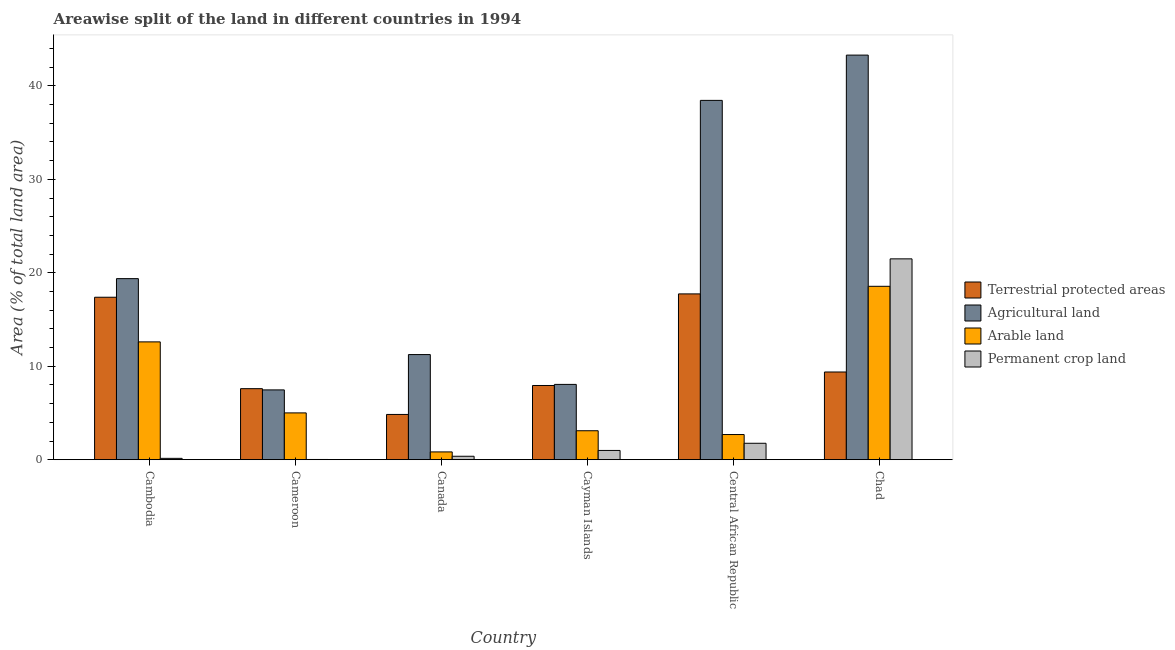How many groups of bars are there?
Your answer should be very brief. 6. Are the number of bars per tick equal to the number of legend labels?
Your answer should be very brief. Yes. Are the number of bars on each tick of the X-axis equal?
Offer a terse response. Yes. What is the label of the 4th group of bars from the left?
Offer a terse response. Cayman Islands. In how many cases, is the number of bars for a given country not equal to the number of legend labels?
Ensure brevity in your answer.  0. What is the percentage of area under agricultural land in Cambodia?
Your answer should be compact. 19.38. Across all countries, what is the maximum percentage of area under arable land?
Keep it short and to the point. 18.56. Across all countries, what is the minimum percentage of land under terrestrial protection?
Offer a terse response. 4.84. In which country was the percentage of land under terrestrial protection maximum?
Give a very brief answer. Central African Republic. In which country was the percentage of area under permanent crop land minimum?
Your answer should be compact. Cameroon. What is the total percentage of area under agricultural land in the graph?
Make the answer very short. 127.91. What is the difference between the percentage of area under arable land in Central African Republic and that in Chad?
Keep it short and to the point. -15.86. What is the difference between the percentage of land under terrestrial protection in Cayman Islands and the percentage of area under permanent crop land in Central African Republic?
Give a very brief answer. 6.18. What is the average percentage of area under permanent crop land per country?
Provide a short and direct response. 4.13. What is the difference between the percentage of area under arable land and percentage of area under permanent crop land in Chad?
Your answer should be very brief. -2.94. What is the ratio of the percentage of area under arable land in Canada to that in Central African Republic?
Ensure brevity in your answer.  0.31. Is the difference between the percentage of area under agricultural land in Cameroon and Central African Republic greater than the difference between the percentage of area under arable land in Cameroon and Central African Republic?
Give a very brief answer. No. What is the difference between the highest and the second highest percentage of area under arable land?
Provide a short and direct response. 5.95. What is the difference between the highest and the lowest percentage of area under permanent crop land?
Your response must be concise. 21.47. Is the sum of the percentage of area under permanent crop land in Cayman Islands and Chad greater than the maximum percentage of land under terrestrial protection across all countries?
Make the answer very short. Yes. What does the 3rd bar from the left in Cameroon represents?
Your answer should be compact. Arable land. What does the 1st bar from the right in Cayman Islands represents?
Make the answer very short. Permanent crop land. Is it the case that in every country, the sum of the percentage of land under terrestrial protection and percentage of area under agricultural land is greater than the percentage of area under arable land?
Keep it short and to the point. Yes. Are all the bars in the graph horizontal?
Make the answer very short. No. Are the values on the major ticks of Y-axis written in scientific E-notation?
Your answer should be very brief. No. Does the graph contain any zero values?
Make the answer very short. No. Does the graph contain grids?
Offer a very short reply. No. Where does the legend appear in the graph?
Offer a very short reply. Center right. How are the legend labels stacked?
Give a very brief answer. Vertical. What is the title of the graph?
Keep it short and to the point. Areawise split of the land in different countries in 1994. What is the label or title of the X-axis?
Your answer should be compact. Country. What is the label or title of the Y-axis?
Provide a succinct answer. Area (% of total land area). What is the Area (% of total land area) in Terrestrial protected areas in Cambodia?
Your answer should be very brief. 17.39. What is the Area (% of total land area) of Agricultural land in Cambodia?
Provide a succinct answer. 19.38. What is the Area (% of total land area) of Arable land in Cambodia?
Give a very brief answer. 12.61. What is the Area (% of total land area) in Permanent crop land in Cambodia?
Your response must be concise. 0.14. What is the Area (% of total land area) in Terrestrial protected areas in Cameroon?
Provide a short and direct response. 7.6. What is the Area (% of total land area) of Agricultural land in Cameroon?
Make the answer very short. 7.47. What is the Area (% of total land area) of Arable land in Cameroon?
Ensure brevity in your answer.  5.01. What is the Area (% of total land area) of Permanent crop land in Cameroon?
Keep it short and to the point. 0.02. What is the Area (% of total land area) of Terrestrial protected areas in Canada?
Offer a terse response. 4.84. What is the Area (% of total land area) of Agricultural land in Canada?
Offer a terse response. 11.25. What is the Area (% of total land area) of Arable land in Canada?
Your response must be concise. 0.83. What is the Area (% of total land area) in Permanent crop land in Canada?
Your response must be concise. 0.37. What is the Area (% of total land area) in Terrestrial protected areas in Cayman Islands?
Your answer should be very brief. 7.94. What is the Area (% of total land area) in Agricultural land in Cayman Islands?
Give a very brief answer. 8.06. What is the Area (% of total land area) in Arable land in Cayman Islands?
Ensure brevity in your answer.  3.1. What is the Area (% of total land area) in Permanent crop land in Cayman Islands?
Keep it short and to the point. 0.99. What is the Area (% of total land area) of Terrestrial protected areas in Central African Republic?
Give a very brief answer. 17.74. What is the Area (% of total land area) in Agricultural land in Central African Republic?
Make the answer very short. 38.45. What is the Area (% of total land area) in Arable land in Central African Republic?
Provide a short and direct response. 2.69. What is the Area (% of total land area) in Permanent crop land in Central African Republic?
Give a very brief answer. 1.76. What is the Area (% of total land area) of Terrestrial protected areas in Chad?
Provide a succinct answer. 9.39. What is the Area (% of total land area) in Agricultural land in Chad?
Provide a short and direct response. 43.3. What is the Area (% of total land area) of Arable land in Chad?
Your answer should be very brief. 18.56. What is the Area (% of total land area) in Permanent crop land in Chad?
Your answer should be very brief. 21.49. Across all countries, what is the maximum Area (% of total land area) of Terrestrial protected areas?
Your answer should be very brief. 17.74. Across all countries, what is the maximum Area (% of total land area) in Agricultural land?
Offer a very short reply. 43.3. Across all countries, what is the maximum Area (% of total land area) in Arable land?
Provide a short and direct response. 18.56. Across all countries, what is the maximum Area (% of total land area) in Permanent crop land?
Your answer should be very brief. 21.49. Across all countries, what is the minimum Area (% of total land area) in Terrestrial protected areas?
Your answer should be compact. 4.84. Across all countries, what is the minimum Area (% of total land area) of Agricultural land?
Provide a short and direct response. 7.47. Across all countries, what is the minimum Area (% of total land area) in Arable land?
Offer a terse response. 0.83. Across all countries, what is the minimum Area (% of total land area) of Permanent crop land?
Your answer should be compact. 0.02. What is the total Area (% of total land area) of Terrestrial protected areas in the graph?
Ensure brevity in your answer.  64.9. What is the total Area (% of total land area) of Agricultural land in the graph?
Offer a terse response. 127.91. What is the total Area (% of total land area) of Arable land in the graph?
Give a very brief answer. 42.8. What is the total Area (% of total land area) of Permanent crop land in the graph?
Offer a very short reply. 24.78. What is the difference between the Area (% of total land area) of Terrestrial protected areas in Cambodia and that in Cameroon?
Offer a very short reply. 9.78. What is the difference between the Area (% of total land area) of Agricultural land in Cambodia and that in Cameroon?
Give a very brief answer. 11.91. What is the difference between the Area (% of total land area) of Arable land in Cambodia and that in Cameroon?
Keep it short and to the point. 7.6. What is the difference between the Area (% of total land area) in Permanent crop land in Cambodia and that in Cameroon?
Provide a short and direct response. 0.12. What is the difference between the Area (% of total land area) of Terrestrial protected areas in Cambodia and that in Canada?
Give a very brief answer. 12.54. What is the difference between the Area (% of total land area) of Agricultural land in Cambodia and that in Canada?
Your response must be concise. 8.13. What is the difference between the Area (% of total land area) of Arable land in Cambodia and that in Canada?
Give a very brief answer. 11.77. What is the difference between the Area (% of total land area) of Permanent crop land in Cambodia and that in Canada?
Offer a very short reply. -0.22. What is the difference between the Area (% of total land area) in Terrestrial protected areas in Cambodia and that in Cayman Islands?
Offer a terse response. 9.45. What is the difference between the Area (% of total land area) in Agricultural land in Cambodia and that in Cayman Islands?
Ensure brevity in your answer.  11.32. What is the difference between the Area (% of total land area) in Arable land in Cambodia and that in Cayman Islands?
Make the answer very short. 9.51. What is the difference between the Area (% of total land area) of Permanent crop land in Cambodia and that in Cayman Islands?
Make the answer very short. -0.85. What is the difference between the Area (% of total land area) in Terrestrial protected areas in Cambodia and that in Central African Republic?
Provide a succinct answer. -0.36. What is the difference between the Area (% of total land area) of Agricultural land in Cambodia and that in Central African Republic?
Your response must be concise. -19.08. What is the difference between the Area (% of total land area) in Arable land in Cambodia and that in Central African Republic?
Your response must be concise. 9.92. What is the difference between the Area (% of total land area) in Permanent crop land in Cambodia and that in Central African Republic?
Make the answer very short. -1.61. What is the difference between the Area (% of total land area) in Terrestrial protected areas in Cambodia and that in Chad?
Your response must be concise. 8. What is the difference between the Area (% of total land area) of Agricultural land in Cambodia and that in Chad?
Offer a terse response. -23.92. What is the difference between the Area (% of total land area) in Arable land in Cambodia and that in Chad?
Your response must be concise. -5.95. What is the difference between the Area (% of total land area) in Permanent crop land in Cambodia and that in Chad?
Your response must be concise. -21.35. What is the difference between the Area (% of total land area) of Terrestrial protected areas in Cameroon and that in Canada?
Provide a succinct answer. 2.76. What is the difference between the Area (% of total land area) in Agricultural land in Cameroon and that in Canada?
Offer a very short reply. -3.78. What is the difference between the Area (% of total land area) in Arable land in Cameroon and that in Canada?
Provide a succinct answer. 4.18. What is the difference between the Area (% of total land area) of Permanent crop land in Cameroon and that in Canada?
Make the answer very short. -0.34. What is the difference between the Area (% of total land area) of Terrestrial protected areas in Cameroon and that in Cayman Islands?
Your answer should be compact. -0.34. What is the difference between the Area (% of total land area) of Agricultural land in Cameroon and that in Cayman Islands?
Your answer should be compact. -0.59. What is the difference between the Area (% of total land area) in Arable land in Cameroon and that in Cayman Islands?
Keep it short and to the point. 1.91. What is the difference between the Area (% of total land area) in Permanent crop land in Cameroon and that in Cayman Islands?
Provide a succinct answer. -0.97. What is the difference between the Area (% of total land area) of Terrestrial protected areas in Cameroon and that in Central African Republic?
Your response must be concise. -10.14. What is the difference between the Area (% of total land area) in Agricultural land in Cameroon and that in Central African Republic?
Make the answer very short. -30.98. What is the difference between the Area (% of total land area) in Arable land in Cameroon and that in Central African Republic?
Provide a short and direct response. 2.32. What is the difference between the Area (% of total land area) in Permanent crop land in Cameroon and that in Central African Republic?
Make the answer very short. -1.73. What is the difference between the Area (% of total land area) in Terrestrial protected areas in Cameroon and that in Chad?
Your response must be concise. -1.78. What is the difference between the Area (% of total land area) of Agricultural land in Cameroon and that in Chad?
Your answer should be very brief. -35.83. What is the difference between the Area (% of total land area) in Arable land in Cameroon and that in Chad?
Ensure brevity in your answer.  -13.55. What is the difference between the Area (% of total land area) in Permanent crop land in Cameroon and that in Chad?
Keep it short and to the point. -21.47. What is the difference between the Area (% of total land area) of Terrestrial protected areas in Canada and that in Cayman Islands?
Keep it short and to the point. -3.1. What is the difference between the Area (% of total land area) in Agricultural land in Canada and that in Cayman Islands?
Provide a short and direct response. 3.19. What is the difference between the Area (% of total land area) of Arable land in Canada and that in Cayman Islands?
Provide a succinct answer. -2.26. What is the difference between the Area (% of total land area) in Permanent crop land in Canada and that in Cayman Islands?
Make the answer very short. -0.62. What is the difference between the Area (% of total land area) in Terrestrial protected areas in Canada and that in Central African Republic?
Make the answer very short. -12.9. What is the difference between the Area (% of total land area) in Agricultural land in Canada and that in Central African Republic?
Your response must be concise. -27.2. What is the difference between the Area (% of total land area) of Arable land in Canada and that in Central African Republic?
Offer a very short reply. -1.86. What is the difference between the Area (% of total land area) in Permanent crop land in Canada and that in Central African Republic?
Your answer should be very brief. -1.39. What is the difference between the Area (% of total land area) of Terrestrial protected areas in Canada and that in Chad?
Your answer should be compact. -4.54. What is the difference between the Area (% of total land area) in Agricultural land in Canada and that in Chad?
Your answer should be very brief. -32.05. What is the difference between the Area (% of total land area) in Arable land in Canada and that in Chad?
Provide a succinct answer. -17.72. What is the difference between the Area (% of total land area) in Permanent crop land in Canada and that in Chad?
Your answer should be compact. -21.13. What is the difference between the Area (% of total land area) in Terrestrial protected areas in Cayman Islands and that in Central African Republic?
Keep it short and to the point. -9.8. What is the difference between the Area (% of total land area) in Agricultural land in Cayman Islands and that in Central African Republic?
Make the answer very short. -30.39. What is the difference between the Area (% of total land area) in Arable land in Cayman Islands and that in Central African Republic?
Offer a terse response. 0.41. What is the difference between the Area (% of total land area) of Permanent crop land in Cayman Islands and that in Central African Republic?
Offer a very short reply. -0.77. What is the difference between the Area (% of total land area) of Terrestrial protected areas in Cayman Islands and that in Chad?
Provide a succinct answer. -1.45. What is the difference between the Area (% of total land area) of Agricultural land in Cayman Islands and that in Chad?
Your answer should be very brief. -35.24. What is the difference between the Area (% of total land area) in Arable land in Cayman Islands and that in Chad?
Provide a short and direct response. -15.46. What is the difference between the Area (% of total land area) in Permanent crop land in Cayman Islands and that in Chad?
Keep it short and to the point. -20.5. What is the difference between the Area (% of total land area) of Terrestrial protected areas in Central African Republic and that in Chad?
Keep it short and to the point. 8.36. What is the difference between the Area (% of total land area) in Agricultural land in Central African Republic and that in Chad?
Offer a very short reply. -4.85. What is the difference between the Area (% of total land area) of Arable land in Central African Republic and that in Chad?
Offer a very short reply. -15.86. What is the difference between the Area (% of total land area) of Permanent crop land in Central African Republic and that in Chad?
Keep it short and to the point. -19.74. What is the difference between the Area (% of total land area) in Terrestrial protected areas in Cambodia and the Area (% of total land area) in Agricultural land in Cameroon?
Give a very brief answer. 9.92. What is the difference between the Area (% of total land area) of Terrestrial protected areas in Cambodia and the Area (% of total land area) of Arable land in Cameroon?
Offer a terse response. 12.38. What is the difference between the Area (% of total land area) of Terrestrial protected areas in Cambodia and the Area (% of total land area) of Permanent crop land in Cameroon?
Give a very brief answer. 17.36. What is the difference between the Area (% of total land area) of Agricultural land in Cambodia and the Area (% of total land area) of Arable land in Cameroon?
Provide a succinct answer. 14.37. What is the difference between the Area (% of total land area) of Agricultural land in Cambodia and the Area (% of total land area) of Permanent crop land in Cameroon?
Your answer should be very brief. 19.35. What is the difference between the Area (% of total land area) in Arable land in Cambodia and the Area (% of total land area) in Permanent crop land in Cameroon?
Provide a succinct answer. 12.58. What is the difference between the Area (% of total land area) in Terrestrial protected areas in Cambodia and the Area (% of total land area) in Agricultural land in Canada?
Your answer should be very brief. 6.14. What is the difference between the Area (% of total land area) of Terrestrial protected areas in Cambodia and the Area (% of total land area) of Arable land in Canada?
Provide a succinct answer. 16.55. What is the difference between the Area (% of total land area) in Terrestrial protected areas in Cambodia and the Area (% of total land area) in Permanent crop land in Canada?
Make the answer very short. 17.02. What is the difference between the Area (% of total land area) in Agricultural land in Cambodia and the Area (% of total land area) in Arable land in Canada?
Provide a succinct answer. 18.54. What is the difference between the Area (% of total land area) of Agricultural land in Cambodia and the Area (% of total land area) of Permanent crop land in Canada?
Keep it short and to the point. 19.01. What is the difference between the Area (% of total land area) in Arable land in Cambodia and the Area (% of total land area) in Permanent crop land in Canada?
Your answer should be very brief. 12.24. What is the difference between the Area (% of total land area) of Terrestrial protected areas in Cambodia and the Area (% of total land area) of Agricultural land in Cayman Islands?
Ensure brevity in your answer.  9.33. What is the difference between the Area (% of total land area) in Terrestrial protected areas in Cambodia and the Area (% of total land area) in Arable land in Cayman Islands?
Offer a very short reply. 14.29. What is the difference between the Area (% of total land area) of Terrestrial protected areas in Cambodia and the Area (% of total land area) of Permanent crop land in Cayman Islands?
Your response must be concise. 16.4. What is the difference between the Area (% of total land area) of Agricultural land in Cambodia and the Area (% of total land area) of Arable land in Cayman Islands?
Your answer should be very brief. 16.28. What is the difference between the Area (% of total land area) of Agricultural land in Cambodia and the Area (% of total land area) of Permanent crop land in Cayman Islands?
Make the answer very short. 18.39. What is the difference between the Area (% of total land area) in Arable land in Cambodia and the Area (% of total land area) in Permanent crop land in Cayman Islands?
Ensure brevity in your answer.  11.62. What is the difference between the Area (% of total land area) in Terrestrial protected areas in Cambodia and the Area (% of total land area) in Agricultural land in Central African Republic?
Provide a succinct answer. -21.07. What is the difference between the Area (% of total land area) in Terrestrial protected areas in Cambodia and the Area (% of total land area) in Arable land in Central African Republic?
Provide a succinct answer. 14.69. What is the difference between the Area (% of total land area) of Terrestrial protected areas in Cambodia and the Area (% of total land area) of Permanent crop land in Central African Republic?
Your answer should be very brief. 15.63. What is the difference between the Area (% of total land area) of Agricultural land in Cambodia and the Area (% of total land area) of Arable land in Central African Republic?
Give a very brief answer. 16.69. What is the difference between the Area (% of total land area) in Agricultural land in Cambodia and the Area (% of total land area) in Permanent crop land in Central African Republic?
Your answer should be very brief. 17.62. What is the difference between the Area (% of total land area) in Arable land in Cambodia and the Area (% of total land area) in Permanent crop land in Central African Republic?
Provide a succinct answer. 10.85. What is the difference between the Area (% of total land area) of Terrestrial protected areas in Cambodia and the Area (% of total land area) of Agricultural land in Chad?
Offer a terse response. -25.91. What is the difference between the Area (% of total land area) of Terrestrial protected areas in Cambodia and the Area (% of total land area) of Arable land in Chad?
Give a very brief answer. -1.17. What is the difference between the Area (% of total land area) in Terrestrial protected areas in Cambodia and the Area (% of total land area) in Permanent crop land in Chad?
Keep it short and to the point. -4.11. What is the difference between the Area (% of total land area) in Agricultural land in Cambodia and the Area (% of total land area) in Arable land in Chad?
Offer a terse response. 0.82. What is the difference between the Area (% of total land area) in Agricultural land in Cambodia and the Area (% of total land area) in Permanent crop land in Chad?
Offer a terse response. -2.12. What is the difference between the Area (% of total land area) of Arable land in Cambodia and the Area (% of total land area) of Permanent crop land in Chad?
Offer a very short reply. -8.89. What is the difference between the Area (% of total land area) in Terrestrial protected areas in Cameroon and the Area (% of total land area) in Agricultural land in Canada?
Offer a terse response. -3.65. What is the difference between the Area (% of total land area) of Terrestrial protected areas in Cameroon and the Area (% of total land area) of Arable land in Canada?
Ensure brevity in your answer.  6.77. What is the difference between the Area (% of total land area) of Terrestrial protected areas in Cameroon and the Area (% of total land area) of Permanent crop land in Canada?
Provide a succinct answer. 7.23. What is the difference between the Area (% of total land area) in Agricultural land in Cameroon and the Area (% of total land area) in Arable land in Canada?
Your answer should be very brief. 6.64. What is the difference between the Area (% of total land area) of Agricultural land in Cameroon and the Area (% of total land area) of Permanent crop land in Canada?
Your answer should be very brief. 7.1. What is the difference between the Area (% of total land area) in Arable land in Cameroon and the Area (% of total land area) in Permanent crop land in Canada?
Ensure brevity in your answer.  4.64. What is the difference between the Area (% of total land area) in Terrestrial protected areas in Cameroon and the Area (% of total land area) in Agricultural land in Cayman Islands?
Ensure brevity in your answer.  -0.46. What is the difference between the Area (% of total land area) of Terrestrial protected areas in Cameroon and the Area (% of total land area) of Arable land in Cayman Islands?
Offer a very short reply. 4.5. What is the difference between the Area (% of total land area) in Terrestrial protected areas in Cameroon and the Area (% of total land area) in Permanent crop land in Cayman Islands?
Keep it short and to the point. 6.61. What is the difference between the Area (% of total land area) in Agricultural land in Cameroon and the Area (% of total land area) in Arable land in Cayman Islands?
Your response must be concise. 4.37. What is the difference between the Area (% of total land area) of Agricultural land in Cameroon and the Area (% of total land area) of Permanent crop land in Cayman Islands?
Give a very brief answer. 6.48. What is the difference between the Area (% of total land area) of Arable land in Cameroon and the Area (% of total land area) of Permanent crop land in Cayman Islands?
Keep it short and to the point. 4.02. What is the difference between the Area (% of total land area) of Terrestrial protected areas in Cameroon and the Area (% of total land area) of Agricultural land in Central African Republic?
Keep it short and to the point. -30.85. What is the difference between the Area (% of total land area) in Terrestrial protected areas in Cameroon and the Area (% of total land area) in Arable land in Central African Republic?
Offer a very short reply. 4.91. What is the difference between the Area (% of total land area) in Terrestrial protected areas in Cameroon and the Area (% of total land area) in Permanent crop land in Central African Republic?
Offer a terse response. 5.84. What is the difference between the Area (% of total land area) in Agricultural land in Cameroon and the Area (% of total land area) in Arable land in Central African Republic?
Make the answer very short. 4.78. What is the difference between the Area (% of total land area) in Agricultural land in Cameroon and the Area (% of total land area) in Permanent crop land in Central African Republic?
Keep it short and to the point. 5.71. What is the difference between the Area (% of total land area) in Arable land in Cameroon and the Area (% of total land area) in Permanent crop land in Central African Republic?
Offer a very short reply. 3.25. What is the difference between the Area (% of total land area) in Terrestrial protected areas in Cameroon and the Area (% of total land area) in Agricultural land in Chad?
Provide a succinct answer. -35.7. What is the difference between the Area (% of total land area) of Terrestrial protected areas in Cameroon and the Area (% of total land area) of Arable land in Chad?
Offer a terse response. -10.95. What is the difference between the Area (% of total land area) in Terrestrial protected areas in Cameroon and the Area (% of total land area) in Permanent crop land in Chad?
Offer a very short reply. -13.89. What is the difference between the Area (% of total land area) in Agricultural land in Cameroon and the Area (% of total land area) in Arable land in Chad?
Your answer should be very brief. -11.09. What is the difference between the Area (% of total land area) of Agricultural land in Cameroon and the Area (% of total land area) of Permanent crop land in Chad?
Your answer should be very brief. -14.02. What is the difference between the Area (% of total land area) of Arable land in Cameroon and the Area (% of total land area) of Permanent crop land in Chad?
Provide a short and direct response. -16.49. What is the difference between the Area (% of total land area) of Terrestrial protected areas in Canada and the Area (% of total land area) of Agricultural land in Cayman Islands?
Keep it short and to the point. -3.22. What is the difference between the Area (% of total land area) of Terrestrial protected areas in Canada and the Area (% of total land area) of Arable land in Cayman Islands?
Provide a short and direct response. 1.74. What is the difference between the Area (% of total land area) in Terrestrial protected areas in Canada and the Area (% of total land area) in Permanent crop land in Cayman Islands?
Your response must be concise. 3.85. What is the difference between the Area (% of total land area) in Agricultural land in Canada and the Area (% of total land area) in Arable land in Cayman Islands?
Offer a terse response. 8.15. What is the difference between the Area (% of total land area) of Agricultural land in Canada and the Area (% of total land area) of Permanent crop land in Cayman Islands?
Give a very brief answer. 10.26. What is the difference between the Area (% of total land area) in Arable land in Canada and the Area (% of total land area) in Permanent crop land in Cayman Islands?
Offer a very short reply. -0.16. What is the difference between the Area (% of total land area) in Terrestrial protected areas in Canada and the Area (% of total land area) in Agricultural land in Central African Republic?
Offer a terse response. -33.61. What is the difference between the Area (% of total land area) of Terrestrial protected areas in Canada and the Area (% of total land area) of Arable land in Central African Republic?
Your response must be concise. 2.15. What is the difference between the Area (% of total land area) in Terrestrial protected areas in Canada and the Area (% of total land area) in Permanent crop land in Central African Republic?
Your response must be concise. 3.08. What is the difference between the Area (% of total land area) of Agricultural land in Canada and the Area (% of total land area) of Arable land in Central African Republic?
Your response must be concise. 8.56. What is the difference between the Area (% of total land area) in Agricultural land in Canada and the Area (% of total land area) in Permanent crop land in Central African Republic?
Make the answer very short. 9.49. What is the difference between the Area (% of total land area) in Arable land in Canada and the Area (% of total land area) in Permanent crop land in Central African Republic?
Keep it short and to the point. -0.92. What is the difference between the Area (% of total land area) of Terrestrial protected areas in Canada and the Area (% of total land area) of Agricultural land in Chad?
Make the answer very short. -38.46. What is the difference between the Area (% of total land area) in Terrestrial protected areas in Canada and the Area (% of total land area) in Arable land in Chad?
Provide a short and direct response. -13.71. What is the difference between the Area (% of total land area) of Terrestrial protected areas in Canada and the Area (% of total land area) of Permanent crop land in Chad?
Provide a short and direct response. -16.65. What is the difference between the Area (% of total land area) of Agricultural land in Canada and the Area (% of total land area) of Arable land in Chad?
Give a very brief answer. -7.31. What is the difference between the Area (% of total land area) of Agricultural land in Canada and the Area (% of total land area) of Permanent crop land in Chad?
Your answer should be very brief. -10.24. What is the difference between the Area (% of total land area) in Arable land in Canada and the Area (% of total land area) in Permanent crop land in Chad?
Make the answer very short. -20.66. What is the difference between the Area (% of total land area) in Terrestrial protected areas in Cayman Islands and the Area (% of total land area) in Agricultural land in Central African Republic?
Offer a terse response. -30.51. What is the difference between the Area (% of total land area) in Terrestrial protected areas in Cayman Islands and the Area (% of total land area) in Arable land in Central African Republic?
Your answer should be compact. 5.25. What is the difference between the Area (% of total land area) of Terrestrial protected areas in Cayman Islands and the Area (% of total land area) of Permanent crop land in Central African Republic?
Keep it short and to the point. 6.18. What is the difference between the Area (% of total land area) in Agricultural land in Cayman Islands and the Area (% of total land area) in Arable land in Central African Republic?
Offer a very short reply. 5.37. What is the difference between the Area (% of total land area) of Agricultural land in Cayman Islands and the Area (% of total land area) of Permanent crop land in Central African Republic?
Provide a short and direct response. 6.3. What is the difference between the Area (% of total land area) in Arable land in Cayman Islands and the Area (% of total land area) in Permanent crop land in Central African Republic?
Keep it short and to the point. 1.34. What is the difference between the Area (% of total land area) of Terrestrial protected areas in Cayman Islands and the Area (% of total land area) of Agricultural land in Chad?
Offer a very short reply. -35.36. What is the difference between the Area (% of total land area) in Terrestrial protected areas in Cayman Islands and the Area (% of total land area) in Arable land in Chad?
Provide a short and direct response. -10.62. What is the difference between the Area (% of total land area) of Terrestrial protected areas in Cayman Islands and the Area (% of total land area) of Permanent crop land in Chad?
Your response must be concise. -13.55. What is the difference between the Area (% of total land area) in Agricultural land in Cayman Islands and the Area (% of total land area) in Arable land in Chad?
Offer a terse response. -10.5. What is the difference between the Area (% of total land area) in Agricultural land in Cayman Islands and the Area (% of total land area) in Permanent crop land in Chad?
Make the answer very short. -13.44. What is the difference between the Area (% of total land area) of Arable land in Cayman Islands and the Area (% of total land area) of Permanent crop land in Chad?
Offer a terse response. -18.4. What is the difference between the Area (% of total land area) of Terrestrial protected areas in Central African Republic and the Area (% of total land area) of Agricultural land in Chad?
Ensure brevity in your answer.  -25.55. What is the difference between the Area (% of total land area) of Terrestrial protected areas in Central African Republic and the Area (% of total land area) of Arable land in Chad?
Offer a terse response. -0.81. What is the difference between the Area (% of total land area) of Terrestrial protected areas in Central African Republic and the Area (% of total land area) of Permanent crop land in Chad?
Provide a short and direct response. -3.75. What is the difference between the Area (% of total land area) of Agricultural land in Central African Republic and the Area (% of total land area) of Arable land in Chad?
Keep it short and to the point. 19.9. What is the difference between the Area (% of total land area) in Agricultural land in Central African Republic and the Area (% of total land area) in Permanent crop land in Chad?
Offer a terse response. 16.96. What is the difference between the Area (% of total land area) of Arable land in Central African Republic and the Area (% of total land area) of Permanent crop land in Chad?
Provide a succinct answer. -18.8. What is the average Area (% of total land area) of Terrestrial protected areas per country?
Offer a terse response. 10.82. What is the average Area (% of total land area) in Agricultural land per country?
Keep it short and to the point. 21.32. What is the average Area (% of total land area) of Arable land per country?
Provide a short and direct response. 7.13. What is the average Area (% of total land area) of Permanent crop land per country?
Offer a terse response. 4.13. What is the difference between the Area (% of total land area) in Terrestrial protected areas and Area (% of total land area) in Agricultural land in Cambodia?
Offer a very short reply. -1.99. What is the difference between the Area (% of total land area) in Terrestrial protected areas and Area (% of total land area) in Arable land in Cambodia?
Give a very brief answer. 4.78. What is the difference between the Area (% of total land area) of Terrestrial protected areas and Area (% of total land area) of Permanent crop land in Cambodia?
Make the answer very short. 17.24. What is the difference between the Area (% of total land area) in Agricultural land and Area (% of total land area) in Arable land in Cambodia?
Keep it short and to the point. 6.77. What is the difference between the Area (% of total land area) in Agricultural land and Area (% of total land area) in Permanent crop land in Cambodia?
Your response must be concise. 19.23. What is the difference between the Area (% of total land area) of Arable land and Area (% of total land area) of Permanent crop land in Cambodia?
Your response must be concise. 12.46. What is the difference between the Area (% of total land area) in Terrestrial protected areas and Area (% of total land area) in Agricultural land in Cameroon?
Make the answer very short. 0.13. What is the difference between the Area (% of total land area) of Terrestrial protected areas and Area (% of total land area) of Arable land in Cameroon?
Provide a succinct answer. 2.59. What is the difference between the Area (% of total land area) of Terrestrial protected areas and Area (% of total land area) of Permanent crop land in Cameroon?
Offer a very short reply. 7.58. What is the difference between the Area (% of total land area) of Agricultural land and Area (% of total land area) of Arable land in Cameroon?
Offer a very short reply. 2.46. What is the difference between the Area (% of total land area) of Agricultural land and Area (% of total land area) of Permanent crop land in Cameroon?
Your answer should be compact. 7.45. What is the difference between the Area (% of total land area) in Arable land and Area (% of total land area) in Permanent crop land in Cameroon?
Your response must be concise. 4.98. What is the difference between the Area (% of total land area) of Terrestrial protected areas and Area (% of total land area) of Agricultural land in Canada?
Keep it short and to the point. -6.41. What is the difference between the Area (% of total land area) of Terrestrial protected areas and Area (% of total land area) of Arable land in Canada?
Offer a very short reply. 4.01. What is the difference between the Area (% of total land area) of Terrestrial protected areas and Area (% of total land area) of Permanent crop land in Canada?
Ensure brevity in your answer.  4.47. What is the difference between the Area (% of total land area) of Agricultural land and Area (% of total land area) of Arable land in Canada?
Provide a short and direct response. 10.42. What is the difference between the Area (% of total land area) in Agricultural land and Area (% of total land area) in Permanent crop land in Canada?
Your answer should be very brief. 10.88. What is the difference between the Area (% of total land area) of Arable land and Area (% of total land area) of Permanent crop land in Canada?
Give a very brief answer. 0.46. What is the difference between the Area (% of total land area) in Terrestrial protected areas and Area (% of total land area) in Agricultural land in Cayman Islands?
Provide a short and direct response. -0.12. What is the difference between the Area (% of total land area) of Terrestrial protected areas and Area (% of total land area) of Arable land in Cayman Islands?
Keep it short and to the point. 4.84. What is the difference between the Area (% of total land area) of Terrestrial protected areas and Area (% of total land area) of Permanent crop land in Cayman Islands?
Your response must be concise. 6.95. What is the difference between the Area (% of total land area) in Agricultural land and Area (% of total land area) in Arable land in Cayman Islands?
Provide a succinct answer. 4.96. What is the difference between the Area (% of total land area) of Agricultural land and Area (% of total land area) of Permanent crop land in Cayman Islands?
Provide a short and direct response. 7.07. What is the difference between the Area (% of total land area) of Arable land and Area (% of total land area) of Permanent crop land in Cayman Islands?
Provide a short and direct response. 2.11. What is the difference between the Area (% of total land area) in Terrestrial protected areas and Area (% of total land area) in Agricultural land in Central African Republic?
Ensure brevity in your answer.  -20.71. What is the difference between the Area (% of total land area) in Terrestrial protected areas and Area (% of total land area) in Arable land in Central African Republic?
Provide a succinct answer. 15.05. What is the difference between the Area (% of total land area) in Terrestrial protected areas and Area (% of total land area) in Permanent crop land in Central African Republic?
Keep it short and to the point. 15.99. What is the difference between the Area (% of total land area) of Agricultural land and Area (% of total land area) of Arable land in Central African Republic?
Ensure brevity in your answer.  35.76. What is the difference between the Area (% of total land area) in Agricultural land and Area (% of total land area) in Permanent crop land in Central African Republic?
Offer a very short reply. 36.7. What is the difference between the Area (% of total land area) of Arable land and Area (% of total land area) of Permanent crop land in Central African Republic?
Keep it short and to the point. 0.93. What is the difference between the Area (% of total land area) of Terrestrial protected areas and Area (% of total land area) of Agricultural land in Chad?
Your answer should be compact. -33.91. What is the difference between the Area (% of total land area) of Terrestrial protected areas and Area (% of total land area) of Arable land in Chad?
Keep it short and to the point. -9.17. What is the difference between the Area (% of total land area) in Terrestrial protected areas and Area (% of total land area) in Permanent crop land in Chad?
Provide a succinct answer. -12.11. What is the difference between the Area (% of total land area) in Agricultural land and Area (% of total land area) in Arable land in Chad?
Make the answer very short. 24.74. What is the difference between the Area (% of total land area) in Agricultural land and Area (% of total land area) in Permanent crop land in Chad?
Your answer should be compact. 21.81. What is the difference between the Area (% of total land area) in Arable land and Area (% of total land area) in Permanent crop land in Chad?
Offer a very short reply. -2.94. What is the ratio of the Area (% of total land area) in Terrestrial protected areas in Cambodia to that in Cameroon?
Ensure brevity in your answer.  2.29. What is the ratio of the Area (% of total land area) of Agricultural land in Cambodia to that in Cameroon?
Make the answer very short. 2.59. What is the ratio of the Area (% of total land area) of Arable land in Cambodia to that in Cameroon?
Your answer should be compact. 2.52. What is the ratio of the Area (% of total land area) in Permanent crop land in Cambodia to that in Cameroon?
Offer a very short reply. 6.06. What is the ratio of the Area (% of total land area) in Terrestrial protected areas in Cambodia to that in Canada?
Make the answer very short. 3.59. What is the ratio of the Area (% of total land area) of Agricultural land in Cambodia to that in Canada?
Ensure brevity in your answer.  1.72. What is the ratio of the Area (% of total land area) in Arable land in Cambodia to that in Canada?
Your answer should be very brief. 15.13. What is the ratio of the Area (% of total land area) in Permanent crop land in Cambodia to that in Canada?
Your answer should be very brief. 0.39. What is the ratio of the Area (% of total land area) in Terrestrial protected areas in Cambodia to that in Cayman Islands?
Your answer should be very brief. 2.19. What is the ratio of the Area (% of total land area) in Agricultural land in Cambodia to that in Cayman Islands?
Offer a terse response. 2.4. What is the ratio of the Area (% of total land area) of Arable land in Cambodia to that in Cayman Islands?
Your answer should be compact. 4.07. What is the ratio of the Area (% of total land area) in Permanent crop land in Cambodia to that in Cayman Islands?
Provide a short and direct response. 0.15. What is the ratio of the Area (% of total land area) of Terrestrial protected areas in Cambodia to that in Central African Republic?
Ensure brevity in your answer.  0.98. What is the ratio of the Area (% of total land area) of Agricultural land in Cambodia to that in Central African Republic?
Your answer should be very brief. 0.5. What is the ratio of the Area (% of total land area) in Arable land in Cambodia to that in Central African Republic?
Keep it short and to the point. 4.68. What is the ratio of the Area (% of total land area) of Permanent crop land in Cambodia to that in Central African Republic?
Offer a terse response. 0.08. What is the ratio of the Area (% of total land area) of Terrestrial protected areas in Cambodia to that in Chad?
Offer a very short reply. 1.85. What is the ratio of the Area (% of total land area) of Agricultural land in Cambodia to that in Chad?
Make the answer very short. 0.45. What is the ratio of the Area (% of total land area) of Arable land in Cambodia to that in Chad?
Your answer should be very brief. 0.68. What is the ratio of the Area (% of total land area) in Permanent crop land in Cambodia to that in Chad?
Your answer should be compact. 0.01. What is the ratio of the Area (% of total land area) of Terrestrial protected areas in Cameroon to that in Canada?
Provide a succinct answer. 1.57. What is the ratio of the Area (% of total land area) of Agricultural land in Cameroon to that in Canada?
Offer a terse response. 0.66. What is the ratio of the Area (% of total land area) of Arable land in Cameroon to that in Canada?
Give a very brief answer. 6.01. What is the ratio of the Area (% of total land area) in Permanent crop land in Cameroon to that in Canada?
Offer a terse response. 0.06. What is the ratio of the Area (% of total land area) of Terrestrial protected areas in Cameroon to that in Cayman Islands?
Your response must be concise. 0.96. What is the ratio of the Area (% of total land area) in Agricultural land in Cameroon to that in Cayman Islands?
Offer a terse response. 0.93. What is the ratio of the Area (% of total land area) of Arable land in Cameroon to that in Cayman Islands?
Provide a succinct answer. 1.62. What is the ratio of the Area (% of total land area) in Permanent crop land in Cameroon to that in Cayman Islands?
Your answer should be very brief. 0.02. What is the ratio of the Area (% of total land area) in Terrestrial protected areas in Cameroon to that in Central African Republic?
Your answer should be compact. 0.43. What is the ratio of the Area (% of total land area) in Agricultural land in Cameroon to that in Central African Republic?
Keep it short and to the point. 0.19. What is the ratio of the Area (% of total land area) in Arable land in Cameroon to that in Central African Republic?
Give a very brief answer. 1.86. What is the ratio of the Area (% of total land area) of Permanent crop land in Cameroon to that in Central African Republic?
Offer a terse response. 0.01. What is the ratio of the Area (% of total land area) in Terrestrial protected areas in Cameroon to that in Chad?
Your response must be concise. 0.81. What is the ratio of the Area (% of total land area) of Agricultural land in Cameroon to that in Chad?
Keep it short and to the point. 0.17. What is the ratio of the Area (% of total land area) in Arable land in Cameroon to that in Chad?
Your answer should be very brief. 0.27. What is the ratio of the Area (% of total land area) of Permanent crop land in Cameroon to that in Chad?
Provide a short and direct response. 0. What is the ratio of the Area (% of total land area) in Terrestrial protected areas in Canada to that in Cayman Islands?
Offer a very short reply. 0.61. What is the ratio of the Area (% of total land area) of Agricultural land in Canada to that in Cayman Islands?
Offer a very short reply. 1.4. What is the ratio of the Area (% of total land area) in Arable land in Canada to that in Cayman Islands?
Your answer should be compact. 0.27. What is the ratio of the Area (% of total land area) of Permanent crop land in Canada to that in Cayman Islands?
Make the answer very short. 0.37. What is the ratio of the Area (% of total land area) of Terrestrial protected areas in Canada to that in Central African Republic?
Make the answer very short. 0.27. What is the ratio of the Area (% of total land area) of Agricultural land in Canada to that in Central African Republic?
Provide a short and direct response. 0.29. What is the ratio of the Area (% of total land area) in Arable land in Canada to that in Central African Republic?
Offer a very short reply. 0.31. What is the ratio of the Area (% of total land area) of Permanent crop land in Canada to that in Central African Republic?
Your answer should be compact. 0.21. What is the ratio of the Area (% of total land area) in Terrestrial protected areas in Canada to that in Chad?
Your response must be concise. 0.52. What is the ratio of the Area (% of total land area) of Agricultural land in Canada to that in Chad?
Ensure brevity in your answer.  0.26. What is the ratio of the Area (% of total land area) of Arable land in Canada to that in Chad?
Provide a short and direct response. 0.04. What is the ratio of the Area (% of total land area) in Permanent crop land in Canada to that in Chad?
Offer a terse response. 0.02. What is the ratio of the Area (% of total land area) of Terrestrial protected areas in Cayman Islands to that in Central African Republic?
Keep it short and to the point. 0.45. What is the ratio of the Area (% of total land area) of Agricultural land in Cayman Islands to that in Central African Republic?
Give a very brief answer. 0.21. What is the ratio of the Area (% of total land area) in Arable land in Cayman Islands to that in Central African Republic?
Provide a short and direct response. 1.15. What is the ratio of the Area (% of total land area) in Permanent crop land in Cayman Islands to that in Central African Republic?
Offer a terse response. 0.56. What is the ratio of the Area (% of total land area) in Terrestrial protected areas in Cayman Islands to that in Chad?
Provide a succinct answer. 0.85. What is the ratio of the Area (% of total land area) in Agricultural land in Cayman Islands to that in Chad?
Offer a terse response. 0.19. What is the ratio of the Area (% of total land area) of Arable land in Cayman Islands to that in Chad?
Provide a succinct answer. 0.17. What is the ratio of the Area (% of total land area) in Permanent crop land in Cayman Islands to that in Chad?
Provide a short and direct response. 0.05. What is the ratio of the Area (% of total land area) in Terrestrial protected areas in Central African Republic to that in Chad?
Offer a very short reply. 1.89. What is the ratio of the Area (% of total land area) in Agricultural land in Central African Republic to that in Chad?
Keep it short and to the point. 0.89. What is the ratio of the Area (% of total land area) of Arable land in Central African Republic to that in Chad?
Offer a terse response. 0.15. What is the ratio of the Area (% of total land area) in Permanent crop land in Central African Republic to that in Chad?
Provide a succinct answer. 0.08. What is the difference between the highest and the second highest Area (% of total land area) of Terrestrial protected areas?
Provide a succinct answer. 0.36. What is the difference between the highest and the second highest Area (% of total land area) in Agricultural land?
Make the answer very short. 4.85. What is the difference between the highest and the second highest Area (% of total land area) in Arable land?
Offer a very short reply. 5.95. What is the difference between the highest and the second highest Area (% of total land area) of Permanent crop land?
Give a very brief answer. 19.74. What is the difference between the highest and the lowest Area (% of total land area) in Terrestrial protected areas?
Your answer should be very brief. 12.9. What is the difference between the highest and the lowest Area (% of total land area) in Agricultural land?
Provide a short and direct response. 35.83. What is the difference between the highest and the lowest Area (% of total land area) of Arable land?
Offer a terse response. 17.72. What is the difference between the highest and the lowest Area (% of total land area) in Permanent crop land?
Ensure brevity in your answer.  21.47. 